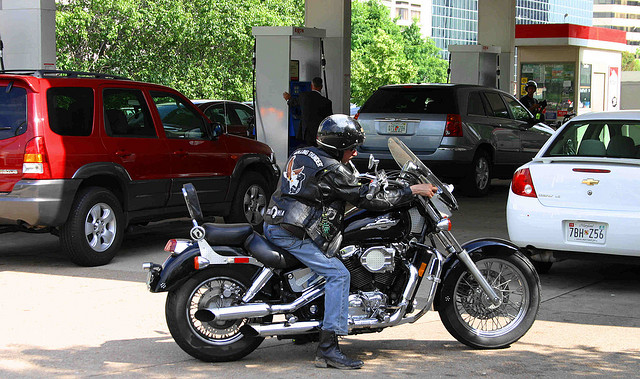Read all the text in this image. Z56 